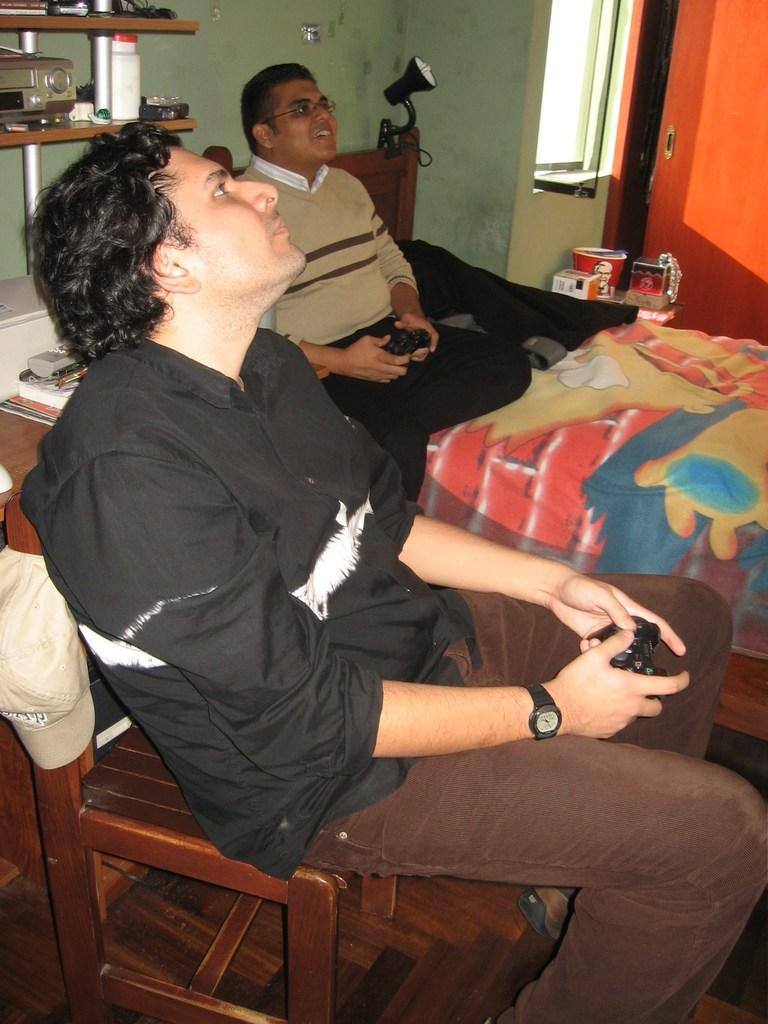Where was the image taken? The image was taken in a room. What are the people in the image doing? The two persons are sitting on chairs. What can be seen behind the people? There is a wall and a shelf behind the people. What type of teeth can be seen on the shelf in the image? There are no teeth present on the shelf in the image. What is the quill used for in the image? There is no quill present in the image. 